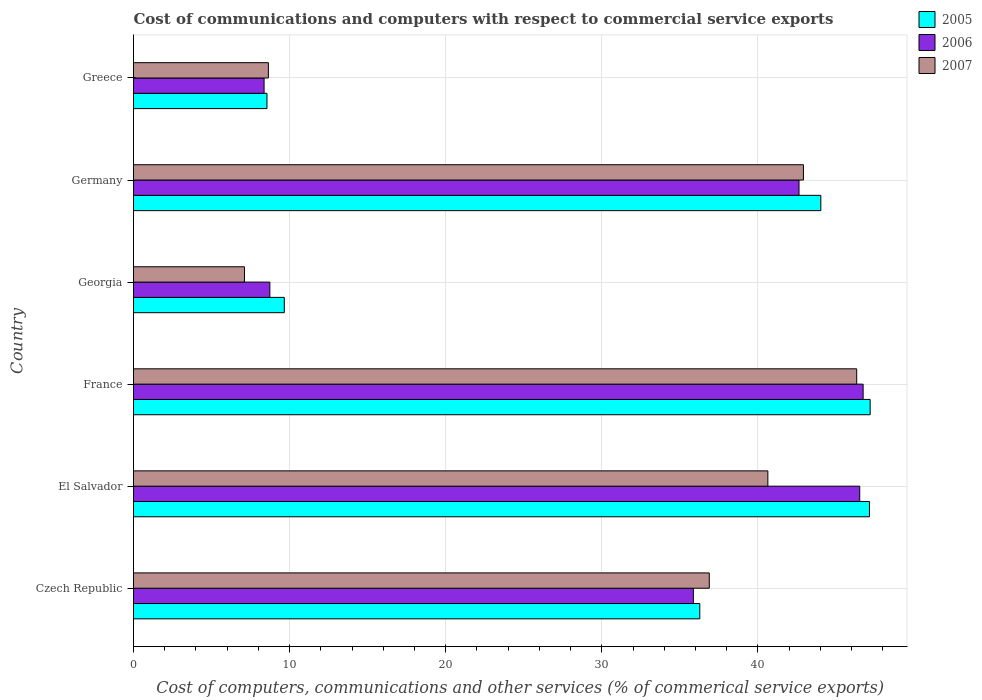How many different coloured bars are there?
Your response must be concise. 3. Are the number of bars per tick equal to the number of legend labels?
Your answer should be very brief. Yes. What is the label of the 5th group of bars from the top?
Offer a very short reply. El Salvador. In how many cases, is the number of bars for a given country not equal to the number of legend labels?
Provide a short and direct response. 0. What is the cost of communications and computers in 2005 in Czech Republic?
Provide a succinct answer. 36.28. Across all countries, what is the maximum cost of communications and computers in 2007?
Keep it short and to the point. 46.33. Across all countries, what is the minimum cost of communications and computers in 2007?
Your answer should be compact. 7.11. In which country was the cost of communications and computers in 2007 minimum?
Offer a terse response. Georgia. What is the total cost of communications and computers in 2006 in the graph?
Ensure brevity in your answer.  188.87. What is the difference between the cost of communications and computers in 2005 in El Salvador and that in Georgia?
Offer a terse response. 37.49. What is the difference between the cost of communications and computers in 2006 in Czech Republic and the cost of communications and computers in 2005 in Germany?
Give a very brief answer. -8.17. What is the average cost of communications and computers in 2007 per country?
Offer a terse response. 30.42. What is the difference between the cost of communications and computers in 2007 and cost of communications and computers in 2005 in Czech Republic?
Give a very brief answer. 0.61. In how many countries, is the cost of communications and computers in 2007 greater than 44 %?
Your response must be concise. 1. What is the ratio of the cost of communications and computers in 2006 in Germany to that in Greece?
Provide a short and direct response. 5.1. Is the cost of communications and computers in 2006 in Czech Republic less than that in Germany?
Provide a succinct answer. Yes. Is the difference between the cost of communications and computers in 2007 in El Salvador and France greater than the difference between the cost of communications and computers in 2005 in El Salvador and France?
Provide a succinct answer. No. What is the difference between the highest and the second highest cost of communications and computers in 2006?
Ensure brevity in your answer.  0.22. What is the difference between the highest and the lowest cost of communications and computers in 2005?
Offer a very short reply. 38.64. Is the sum of the cost of communications and computers in 2006 in Czech Republic and France greater than the maximum cost of communications and computers in 2007 across all countries?
Your response must be concise. Yes. How many bars are there?
Ensure brevity in your answer.  18. Are all the bars in the graph horizontal?
Keep it short and to the point. Yes. How many countries are there in the graph?
Give a very brief answer. 6. What is the difference between two consecutive major ticks on the X-axis?
Your answer should be very brief. 10. Does the graph contain grids?
Your response must be concise. Yes. How many legend labels are there?
Provide a succinct answer. 3. What is the title of the graph?
Offer a terse response. Cost of communications and computers with respect to commercial service exports. Does "1989" appear as one of the legend labels in the graph?
Provide a succinct answer. No. What is the label or title of the X-axis?
Your response must be concise. Cost of computers, communications and other services (% of commerical service exports). What is the label or title of the Y-axis?
Offer a very short reply. Country. What is the Cost of computers, communications and other services (% of commerical service exports) of 2005 in Czech Republic?
Make the answer very short. 36.28. What is the Cost of computers, communications and other services (% of commerical service exports) of 2006 in Czech Republic?
Provide a succinct answer. 35.87. What is the Cost of computers, communications and other services (% of commerical service exports) of 2007 in Czech Republic?
Your response must be concise. 36.89. What is the Cost of computers, communications and other services (% of commerical service exports) of 2005 in El Salvador?
Make the answer very short. 47.15. What is the Cost of computers, communications and other services (% of commerical service exports) of 2006 in El Salvador?
Give a very brief answer. 46.53. What is the Cost of computers, communications and other services (% of commerical service exports) of 2007 in El Salvador?
Keep it short and to the point. 40.64. What is the Cost of computers, communications and other services (% of commerical service exports) of 2005 in France?
Your response must be concise. 47.19. What is the Cost of computers, communications and other services (% of commerical service exports) in 2006 in France?
Provide a succinct answer. 46.74. What is the Cost of computers, communications and other services (% of commerical service exports) in 2007 in France?
Give a very brief answer. 46.33. What is the Cost of computers, communications and other services (% of commerical service exports) in 2005 in Georgia?
Your answer should be compact. 9.66. What is the Cost of computers, communications and other services (% of commerical service exports) in 2006 in Georgia?
Give a very brief answer. 8.74. What is the Cost of computers, communications and other services (% of commerical service exports) of 2007 in Georgia?
Your answer should be compact. 7.11. What is the Cost of computers, communications and other services (% of commerical service exports) in 2005 in Germany?
Keep it short and to the point. 44.03. What is the Cost of computers, communications and other services (% of commerical service exports) in 2006 in Germany?
Provide a succinct answer. 42.64. What is the Cost of computers, communications and other services (% of commerical service exports) in 2007 in Germany?
Provide a short and direct response. 42.92. What is the Cost of computers, communications and other services (% of commerical service exports) in 2005 in Greece?
Make the answer very short. 8.55. What is the Cost of computers, communications and other services (% of commerical service exports) of 2006 in Greece?
Your answer should be compact. 8.36. What is the Cost of computers, communications and other services (% of commerical service exports) in 2007 in Greece?
Offer a terse response. 8.64. Across all countries, what is the maximum Cost of computers, communications and other services (% of commerical service exports) in 2005?
Give a very brief answer. 47.19. Across all countries, what is the maximum Cost of computers, communications and other services (% of commerical service exports) in 2006?
Ensure brevity in your answer.  46.74. Across all countries, what is the maximum Cost of computers, communications and other services (% of commerical service exports) in 2007?
Give a very brief answer. 46.33. Across all countries, what is the minimum Cost of computers, communications and other services (% of commerical service exports) of 2005?
Give a very brief answer. 8.55. Across all countries, what is the minimum Cost of computers, communications and other services (% of commerical service exports) of 2006?
Provide a succinct answer. 8.36. Across all countries, what is the minimum Cost of computers, communications and other services (% of commerical service exports) of 2007?
Provide a short and direct response. 7.11. What is the total Cost of computers, communications and other services (% of commerical service exports) in 2005 in the graph?
Your answer should be compact. 192.87. What is the total Cost of computers, communications and other services (% of commerical service exports) of 2006 in the graph?
Keep it short and to the point. 188.87. What is the total Cost of computers, communications and other services (% of commerical service exports) in 2007 in the graph?
Your answer should be compact. 182.53. What is the difference between the Cost of computers, communications and other services (% of commerical service exports) of 2005 in Czech Republic and that in El Salvador?
Keep it short and to the point. -10.87. What is the difference between the Cost of computers, communications and other services (% of commerical service exports) in 2006 in Czech Republic and that in El Salvador?
Give a very brief answer. -10.66. What is the difference between the Cost of computers, communications and other services (% of commerical service exports) in 2007 in Czech Republic and that in El Salvador?
Offer a very short reply. -3.75. What is the difference between the Cost of computers, communications and other services (% of commerical service exports) in 2005 in Czech Republic and that in France?
Your response must be concise. -10.92. What is the difference between the Cost of computers, communications and other services (% of commerical service exports) in 2006 in Czech Republic and that in France?
Your answer should be compact. -10.88. What is the difference between the Cost of computers, communications and other services (% of commerical service exports) in 2007 in Czech Republic and that in France?
Offer a terse response. -9.44. What is the difference between the Cost of computers, communications and other services (% of commerical service exports) of 2005 in Czech Republic and that in Georgia?
Your response must be concise. 26.62. What is the difference between the Cost of computers, communications and other services (% of commerical service exports) in 2006 in Czech Republic and that in Georgia?
Ensure brevity in your answer.  27.13. What is the difference between the Cost of computers, communications and other services (% of commerical service exports) of 2007 in Czech Republic and that in Georgia?
Your response must be concise. 29.78. What is the difference between the Cost of computers, communications and other services (% of commerical service exports) of 2005 in Czech Republic and that in Germany?
Ensure brevity in your answer.  -7.75. What is the difference between the Cost of computers, communications and other services (% of commerical service exports) of 2006 in Czech Republic and that in Germany?
Your answer should be very brief. -6.77. What is the difference between the Cost of computers, communications and other services (% of commerical service exports) in 2007 in Czech Republic and that in Germany?
Your answer should be very brief. -6.03. What is the difference between the Cost of computers, communications and other services (% of commerical service exports) of 2005 in Czech Republic and that in Greece?
Provide a short and direct response. 27.73. What is the difference between the Cost of computers, communications and other services (% of commerical service exports) in 2006 in Czech Republic and that in Greece?
Your answer should be compact. 27.5. What is the difference between the Cost of computers, communications and other services (% of commerical service exports) in 2007 in Czech Republic and that in Greece?
Provide a short and direct response. 28.25. What is the difference between the Cost of computers, communications and other services (% of commerical service exports) in 2005 in El Salvador and that in France?
Offer a terse response. -0.04. What is the difference between the Cost of computers, communications and other services (% of commerical service exports) of 2006 in El Salvador and that in France?
Make the answer very short. -0.22. What is the difference between the Cost of computers, communications and other services (% of commerical service exports) of 2007 in El Salvador and that in France?
Give a very brief answer. -5.69. What is the difference between the Cost of computers, communications and other services (% of commerical service exports) of 2005 in El Salvador and that in Georgia?
Offer a very short reply. 37.49. What is the difference between the Cost of computers, communications and other services (% of commerical service exports) in 2006 in El Salvador and that in Georgia?
Offer a very short reply. 37.79. What is the difference between the Cost of computers, communications and other services (% of commerical service exports) of 2007 in El Salvador and that in Georgia?
Give a very brief answer. 33.53. What is the difference between the Cost of computers, communications and other services (% of commerical service exports) in 2005 in El Salvador and that in Germany?
Keep it short and to the point. 3.12. What is the difference between the Cost of computers, communications and other services (% of commerical service exports) in 2006 in El Salvador and that in Germany?
Provide a short and direct response. 3.89. What is the difference between the Cost of computers, communications and other services (% of commerical service exports) of 2007 in El Salvador and that in Germany?
Provide a succinct answer. -2.28. What is the difference between the Cost of computers, communications and other services (% of commerical service exports) of 2005 in El Salvador and that in Greece?
Your answer should be compact. 38.6. What is the difference between the Cost of computers, communications and other services (% of commerical service exports) of 2006 in El Salvador and that in Greece?
Provide a short and direct response. 38.16. What is the difference between the Cost of computers, communications and other services (% of commerical service exports) of 2007 in El Salvador and that in Greece?
Give a very brief answer. 32. What is the difference between the Cost of computers, communications and other services (% of commerical service exports) in 2005 in France and that in Georgia?
Keep it short and to the point. 37.53. What is the difference between the Cost of computers, communications and other services (% of commerical service exports) in 2006 in France and that in Georgia?
Your answer should be compact. 38.01. What is the difference between the Cost of computers, communications and other services (% of commerical service exports) of 2007 in France and that in Georgia?
Make the answer very short. 39.22. What is the difference between the Cost of computers, communications and other services (% of commerical service exports) of 2005 in France and that in Germany?
Offer a terse response. 3.16. What is the difference between the Cost of computers, communications and other services (% of commerical service exports) in 2006 in France and that in Germany?
Give a very brief answer. 4.11. What is the difference between the Cost of computers, communications and other services (% of commerical service exports) in 2007 in France and that in Germany?
Give a very brief answer. 3.41. What is the difference between the Cost of computers, communications and other services (% of commerical service exports) of 2005 in France and that in Greece?
Offer a terse response. 38.64. What is the difference between the Cost of computers, communications and other services (% of commerical service exports) in 2006 in France and that in Greece?
Your response must be concise. 38.38. What is the difference between the Cost of computers, communications and other services (% of commerical service exports) of 2007 in France and that in Greece?
Your answer should be compact. 37.69. What is the difference between the Cost of computers, communications and other services (% of commerical service exports) in 2005 in Georgia and that in Germany?
Make the answer very short. -34.37. What is the difference between the Cost of computers, communications and other services (% of commerical service exports) of 2006 in Georgia and that in Germany?
Make the answer very short. -33.9. What is the difference between the Cost of computers, communications and other services (% of commerical service exports) in 2007 in Georgia and that in Germany?
Give a very brief answer. -35.81. What is the difference between the Cost of computers, communications and other services (% of commerical service exports) of 2005 in Georgia and that in Greece?
Your answer should be compact. 1.11. What is the difference between the Cost of computers, communications and other services (% of commerical service exports) of 2006 in Georgia and that in Greece?
Your answer should be compact. 0.37. What is the difference between the Cost of computers, communications and other services (% of commerical service exports) in 2007 in Georgia and that in Greece?
Provide a short and direct response. -1.53. What is the difference between the Cost of computers, communications and other services (% of commerical service exports) in 2005 in Germany and that in Greece?
Give a very brief answer. 35.48. What is the difference between the Cost of computers, communications and other services (% of commerical service exports) in 2006 in Germany and that in Greece?
Keep it short and to the point. 34.27. What is the difference between the Cost of computers, communications and other services (% of commerical service exports) of 2007 in Germany and that in Greece?
Your response must be concise. 34.28. What is the difference between the Cost of computers, communications and other services (% of commerical service exports) in 2005 in Czech Republic and the Cost of computers, communications and other services (% of commerical service exports) in 2006 in El Salvador?
Make the answer very short. -10.25. What is the difference between the Cost of computers, communications and other services (% of commerical service exports) in 2005 in Czech Republic and the Cost of computers, communications and other services (% of commerical service exports) in 2007 in El Salvador?
Your response must be concise. -4.36. What is the difference between the Cost of computers, communications and other services (% of commerical service exports) in 2006 in Czech Republic and the Cost of computers, communications and other services (% of commerical service exports) in 2007 in El Salvador?
Offer a terse response. -4.77. What is the difference between the Cost of computers, communications and other services (% of commerical service exports) of 2005 in Czech Republic and the Cost of computers, communications and other services (% of commerical service exports) of 2006 in France?
Keep it short and to the point. -10.46. What is the difference between the Cost of computers, communications and other services (% of commerical service exports) in 2005 in Czech Republic and the Cost of computers, communications and other services (% of commerical service exports) in 2007 in France?
Provide a succinct answer. -10.05. What is the difference between the Cost of computers, communications and other services (% of commerical service exports) in 2006 in Czech Republic and the Cost of computers, communications and other services (% of commerical service exports) in 2007 in France?
Give a very brief answer. -10.46. What is the difference between the Cost of computers, communications and other services (% of commerical service exports) of 2005 in Czech Republic and the Cost of computers, communications and other services (% of commerical service exports) of 2006 in Georgia?
Provide a succinct answer. 27.54. What is the difference between the Cost of computers, communications and other services (% of commerical service exports) in 2005 in Czech Republic and the Cost of computers, communications and other services (% of commerical service exports) in 2007 in Georgia?
Your answer should be very brief. 29.17. What is the difference between the Cost of computers, communications and other services (% of commerical service exports) in 2006 in Czech Republic and the Cost of computers, communications and other services (% of commerical service exports) in 2007 in Georgia?
Offer a terse response. 28.76. What is the difference between the Cost of computers, communications and other services (% of commerical service exports) in 2005 in Czech Republic and the Cost of computers, communications and other services (% of commerical service exports) in 2006 in Germany?
Make the answer very short. -6.36. What is the difference between the Cost of computers, communications and other services (% of commerical service exports) of 2005 in Czech Republic and the Cost of computers, communications and other services (% of commerical service exports) of 2007 in Germany?
Your answer should be compact. -6.64. What is the difference between the Cost of computers, communications and other services (% of commerical service exports) in 2006 in Czech Republic and the Cost of computers, communications and other services (% of commerical service exports) in 2007 in Germany?
Provide a short and direct response. -7.05. What is the difference between the Cost of computers, communications and other services (% of commerical service exports) of 2005 in Czech Republic and the Cost of computers, communications and other services (% of commerical service exports) of 2006 in Greece?
Make the answer very short. 27.91. What is the difference between the Cost of computers, communications and other services (% of commerical service exports) of 2005 in Czech Republic and the Cost of computers, communications and other services (% of commerical service exports) of 2007 in Greece?
Make the answer very short. 27.64. What is the difference between the Cost of computers, communications and other services (% of commerical service exports) in 2006 in Czech Republic and the Cost of computers, communications and other services (% of commerical service exports) in 2007 in Greece?
Make the answer very short. 27.23. What is the difference between the Cost of computers, communications and other services (% of commerical service exports) in 2005 in El Salvador and the Cost of computers, communications and other services (% of commerical service exports) in 2006 in France?
Give a very brief answer. 0.41. What is the difference between the Cost of computers, communications and other services (% of commerical service exports) in 2005 in El Salvador and the Cost of computers, communications and other services (% of commerical service exports) in 2007 in France?
Your answer should be compact. 0.82. What is the difference between the Cost of computers, communications and other services (% of commerical service exports) of 2006 in El Salvador and the Cost of computers, communications and other services (% of commerical service exports) of 2007 in France?
Make the answer very short. 0.19. What is the difference between the Cost of computers, communications and other services (% of commerical service exports) in 2005 in El Salvador and the Cost of computers, communications and other services (% of commerical service exports) in 2006 in Georgia?
Your answer should be compact. 38.41. What is the difference between the Cost of computers, communications and other services (% of commerical service exports) in 2005 in El Salvador and the Cost of computers, communications and other services (% of commerical service exports) in 2007 in Georgia?
Your answer should be very brief. 40.04. What is the difference between the Cost of computers, communications and other services (% of commerical service exports) of 2006 in El Salvador and the Cost of computers, communications and other services (% of commerical service exports) of 2007 in Georgia?
Offer a very short reply. 39.42. What is the difference between the Cost of computers, communications and other services (% of commerical service exports) in 2005 in El Salvador and the Cost of computers, communications and other services (% of commerical service exports) in 2006 in Germany?
Your response must be concise. 4.51. What is the difference between the Cost of computers, communications and other services (% of commerical service exports) of 2005 in El Salvador and the Cost of computers, communications and other services (% of commerical service exports) of 2007 in Germany?
Make the answer very short. 4.23. What is the difference between the Cost of computers, communications and other services (% of commerical service exports) of 2006 in El Salvador and the Cost of computers, communications and other services (% of commerical service exports) of 2007 in Germany?
Give a very brief answer. 3.61. What is the difference between the Cost of computers, communications and other services (% of commerical service exports) of 2005 in El Salvador and the Cost of computers, communications and other services (% of commerical service exports) of 2006 in Greece?
Provide a short and direct response. 38.78. What is the difference between the Cost of computers, communications and other services (% of commerical service exports) in 2005 in El Salvador and the Cost of computers, communications and other services (% of commerical service exports) in 2007 in Greece?
Your answer should be very brief. 38.51. What is the difference between the Cost of computers, communications and other services (% of commerical service exports) in 2006 in El Salvador and the Cost of computers, communications and other services (% of commerical service exports) in 2007 in Greece?
Make the answer very short. 37.89. What is the difference between the Cost of computers, communications and other services (% of commerical service exports) in 2005 in France and the Cost of computers, communications and other services (% of commerical service exports) in 2006 in Georgia?
Keep it short and to the point. 38.46. What is the difference between the Cost of computers, communications and other services (% of commerical service exports) in 2005 in France and the Cost of computers, communications and other services (% of commerical service exports) in 2007 in Georgia?
Your answer should be compact. 40.09. What is the difference between the Cost of computers, communications and other services (% of commerical service exports) in 2006 in France and the Cost of computers, communications and other services (% of commerical service exports) in 2007 in Georgia?
Make the answer very short. 39.64. What is the difference between the Cost of computers, communications and other services (% of commerical service exports) of 2005 in France and the Cost of computers, communications and other services (% of commerical service exports) of 2006 in Germany?
Your response must be concise. 4.56. What is the difference between the Cost of computers, communications and other services (% of commerical service exports) of 2005 in France and the Cost of computers, communications and other services (% of commerical service exports) of 2007 in Germany?
Provide a short and direct response. 4.28. What is the difference between the Cost of computers, communications and other services (% of commerical service exports) in 2006 in France and the Cost of computers, communications and other services (% of commerical service exports) in 2007 in Germany?
Ensure brevity in your answer.  3.83. What is the difference between the Cost of computers, communications and other services (% of commerical service exports) in 2005 in France and the Cost of computers, communications and other services (% of commerical service exports) in 2006 in Greece?
Your answer should be compact. 38.83. What is the difference between the Cost of computers, communications and other services (% of commerical service exports) in 2005 in France and the Cost of computers, communications and other services (% of commerical service exports) in 2007 in Greece?
Ensure brevity in your answer.  38.55. What is the difference between the Cost of computers, communications and other services (% of commerical service exports) in 2006 in France and the Cost of computers, communications and other services (% of commerical service exports) in 2007 in Greece?
Your response must be concise. 38.1. What is the difference between the Cost of computers, communications and other services (% of commerical service exports) in 2005 in Georgia and the Cost of computers, communications and other services (% of commerical service exports) in 2006 in Germany?
Give a very brief answer. -32.98. What is the difference between the Cost of computers, communications and other services (% of commerical service exports) of 2005 in Georgia and the Cost of computers, communications and other services (% of commerical service exports) of 2007 in Germany?
Your response must be concise. -33.26. What is the difference between the Cost of computers, communications and other services (% of commerical service exports) in 2006 in Georgia and the Cost of computers, communications and other services (% of commerical service exports) in 2007 in Germany?
Provide a short and direct response. -34.18. What is the difference between the Cost of computers, communications and other services (% of commerical service exports) of 2005 in Georgia and the Cost of computers, communications and other services (% of commerical service exports) of 2006 in Greece?
Provide a succinct answer. 1.3. What is the difference between the Cost of computers, communications and other services (% of commerical service exports) in 2005 in Georgia and the Cost of computers, communications and other services (% of commerical service exports) in 2007 in Greece?
Offer a terse response. 1.02. What is the difference between the Cost of computers, communications and other services (% of commerical service exports) in 2006 in Georgia and the Cost of computers, communications and other services (% of commerical service exports) in 2007 in Greece?
Provide a short and direct response. 0.1. What is the difference between the Cost of computers, communications and other services (% of commerical service exports) of 2005 in Germany and the Cost of computers, communications and other services (% of commerical service exports) of 2006 in Greece?
Your answer should be compact. 35.67. What is the difference between the Cost of computers, communications and other services (% of commerical service exports) of 2005 in Germany and the Cost of computers, communications and other services (% of commerical service exports) of 2007 in Greece?
Provide a succinct answer. 35.39. What is the difference between the Cost of computers, communications and other services (% of commerical service exports) in 2006 in Germany and the Cost of computers, communications and other services (% of commerical service exports) in 2007 in Greece?
Offer a terse response. 34. What is the average Cost of computers, communications and other services (% of commerical service exports) of 2005 per country?
Your answer should be very brief. 32.14. What is the average Cost of computers, communications and other services (% of commerical service exports) in 2006 per country?
Your answer should be compact. 31.48. What is the average Cost of computers, communications and other services (% of commerical service exports) in 2007 per country?
Give a very brief answer. 30.42. What is the difference between the Cost of computers, communications and other services (% of commerical service exports) in 2005 and Cost of computers, communications and other services (% of commerical service exports) in 2006 in Czech Republic?
Your answer should be compact. 0.41. What is the difference between the Cost of computers, communications and other services (% of commerical service exports) in 2005 and Cost of computers, communications and other services (% of commerical service exports) in 2007 in Czech Republic?
Offer a very short reply. -0.61. What is the difference between the Cost of computers, communications and other services (% of commerical service exports) in 2006 and Cost of computers, communications and other services (% of commerical service exports) in 2007 in Czech Republic?
Your answer should be very brief. -1.02. What is the difference between the Cost of computers, communications and other services (% of commerical service exports) in 2005 and Cost of computers, communications and other services (% of commerical service exports) in 2006 in El Salvador?
Your answer should be compact. 0.62. What is the difference between the Cost of computers, communications and other services (% of commerical service exports) in 2005 and Cost of computers, communications and other services (% of commerical service exports) in 2007 in El Salvador?
Provide a succinct answer. 6.51. What is the difference between the Cost of computers, communications and other services (% of commerical service exports) in 2006 and Cost of computers, communications and other services (% of commerical service exports) in 2007 in El Salvador?
Ensure brevity in your answer.  5.89. What is the difference between the Cost of computers, communications and other services (% of commerical service exports) of 2005 and Cost of computers, communications and other services (% of commerical service exports) of 2006 in France?
Offer a very short reply. 0.45. What is the difference between the Cost of computers, communications and other services (% of commerical service exports) in 2005 and Cost of computers, communications and other services (% of commerical service exports) in 2007 in France?
Provide a succinct answer. 0.86. What is the difference between the Cost of computers, communications and other services (% of commerical service exports) in 2006 and Cost of computers, communications and other services (% of commerical service exports) in 2007 in France?
Ensure brevity in your answer.  0.41. What is the difference between the Cost of computers, communications and other services (% of commerical service exports) in 2005 and Cost of computers, communications and other services (% of commerical service exports) in 2006 in Georgia?
Provide a short and direct response. 0.93. What is the difference between the Cost of computers, communications and other services (% of commerical service exports) in 2005 and Cost of computers, communications and other services (% of commerical service exports) in 2007 in Georgia?
Provide a succinct answer. 2.55. What is the difference between the Cost of computers, communications and other services (% of commerical service exports) in 2006 and Cost of computers, communications and other services (% of commerical service exports) in 2007 in Georgia?
Your answer should be very brief. 1.63. What is the difference between the Cost of computers, communications and other services (% of commerical service exports) of 2005 and Cost of computers, communications and other services (% of commerical service exports) of 2006 in Germany?
Provide a succinct answer. 1.4. What is the difference between the Cost of computers, communications and other services (% of commerical service exports) in 2005 and Cost of computers, communications and other services (% of commerical service exports) in 2007 in Germany?
Ensure brevity in your answer.  1.11. What is the difference between the Cost of computers, communications and other services (% of commerical service exports) of 2006 and Cost of computers, communications and other services (% of commerical service exports) of 2007 in Germany?
Make the answer very short. -0.28. What is the difference between the Cost of computers, communications and other services (% of commerical service exports) in 2005 and Cost of computers, communications and other services (% of commerical service exports) in 2006 in Greece?
Your answer should be very brief. 0.19. What is the difference between the Cost of computers, communications and other services (% of commerical service exports) in 2005 and Cost of computers, communications and other services (% of commerical service exports) in 2007 in Greece?
Provide a short and direct response. -0.09. What is the difference between the Cost of computers, communications and other services (% of commerical service exports) in 2006 and Cost of computers, communications and other services (% of commerical service exports) in 2007 in Greece?
Offer a terse response. -0.28. What is the ratio of the Cost of computers, communications and other services (% of commerical service exports) of 2005 in Czech Republic to that in El Salvador?
Keep it short and to the point. 0.77. What is the ratio of the Cost of computers, communications and other services (% of commerical service exports) of 2006 in Czech Republic to that in El Salvador?
Make the answer very short. 0.77. What is the ratio of the Cost of computers, communications and other services (% of commerical service exports) of 2007 in Czech Republic to that in El Salvador?
Ensure brevity in your answer.  0.91. What is the ratio of the Cost of computers, communications and other services (% of commerical service exports) in 2005 in Czech Republic to that in France?
Your answer should be very brief. 0.77. What is the ratio of the Cost of computers, communications and other services (% of commerical service exports) of 2006 in Czech Republic to that in France?
Give a very brief answer. 0.77. What is the ratio of the Cost of computers, communications and other services (% of commerical service exports) of 2007 in Czech Republic to that in France?
Your answer should be very brief. 0.8. What is the ratio of the Cost of computers, communications and other services (% of commerical service exports) in 2005 in Czech Republic to that in Georgia?
Provide a succinct answer. 3.76. What is the ratio of the Cost of computers, communications and other services (% of commerical service exports) of 2006 in Czech Republic to that in Georgia?
Offer a very short reply. 4.11. What is the ratio of the Cost of computers, communications and other services (% of commerical service exports) of 2007 in Czech Republic to that in Georgia?
Give a very brief answer. 5.19. What is the ratio of the Cost of computers, communications and other services (% of commerical service exports) of 2005 in Czech Republic to that in Germany?
Your answer should be very brief. 0.82. What is the ratio of the Cost of computers, communications and other services (% of commerical service exports) of 2006 in Czech Republic to that in Germany?
Make the answer very short. 0.84. What is the ratio of the Cost of computers, communications and other services (% of commerical service exports) of 2007 in Czech Republic to that in Germany?
Give a very brief answer. 0.86. What is the ratio of the Cost of computers, communications and other services (% of commerical service exports) in 2005 in Czech Republic to that in Greece?
Make the answer very short. 4.24. What is the ratio of the Cost of computers, communications and other services (% of commerical service exports) of 2006 in Czech Republic to that in Greece?
Provide a short and direct response. 4.29. What is the ratio of the Cost of computers, communications and other services (% of commerical service exports) in 2007 in Czech Republic to that in Greece?
Keep it short and to the point. 4.27. What is the ratio of the Cost of computers, communications and other services (% of commerical service exports) of 2006 in El Salvador to that in France?
Give a very brief answer. 1. What is the ratio of the Cost of computers, communications and other services (% of commerical service exports) in 2007 in El Salvador to that in France?
Keep it short and to the point. 0.88. What is the ratio of the Cost of computers, communications and other services (% of commerical service exports) in 2005 in El Salvador to that in Georgia?
Your response must be concise. 4.88. What is the ratio of the Cost of computers, communications and other services (% of commerical service exports) in 2006 in El Salvador to that in Georgia?
Keep it short and to the point. 5.33. What is the ratio of the Cost of computers, communications and other services (% of commerical service exports) in 2007 in El Salvador to that in Georgia?
Provide a succinct answer. 5.72. What is the ratio of the Cost of computers, communications and other services (% of commerical service exports) of 2005 in El Salvador to that in Germany?
Offer a terse response. 1.07. What is the ratio of the Cost of computers, communications and other services (% of commerical service exports) in 2006 in El Salvador to that in Germany?
Ensure brevity in your answer.  1.09. What is the ratio of the Cost of computers, communications and other services (% of commerical service exports) of 2007 in El Salvador to that in Germany?
Provide a succinct answer. 0.95. What is the ratio of the Cost of computers, communications and other services (% of commerical service exports) in 2005 in El Salvador to that in Greece?
Your answer should be very brief. 5.51. What is the ratio of the Cost of computers, communications and other services (% of commerical service exports) of 2006 in El Salvador to that in Greece?
Provide a short and direct response. 5.56. What is the ratio of the Cost of computers, communications and other services (% of commerical service exports) of 2007 in El Salvador to that in Greece?
Your response must be concise. 4.7. What is the ratio of the Cost of computers, communications and other services (% of commerical service exports) of 2005 in France to that in Georgia?
Your response must be concise. 4.89. What is the ratio of the Cost of computers, communications and other services (% of commerical service exports) of 2006 in France to that in Georgia?
Make the answer very short. 5.35. What is the ratio of the Cost of computers, communications and other services (% of commerical service exports) in 2007 in France to that in Georgia?
Make the answer very short. 6.52. What is the ratio of the Cost of computers, communications and other services (% of commerical service exports) of 2005 in France to that in Germany?
Keep it short and to the point. 1.07. What is the ratio of the Cost of computers, communications and other services (% of commerical service exports) in 2006 in France to that in Germany?
Your response must be concise. 1.1. What is the ratio of the Cost of computers, communications and other services (% of commerical service exports) of 2007 in France to that in Germany?
Ensure brevity in your answer.  1.08. What is the ratio of the Cost of computers, communications and other services (% of commerical service exports) of 2005 in France to that in Greece?
Your answer should be compact. 5.52. What is the ratio of the Cost of computers, communications and other services (% of commerical service exports) of 2006 in France to that in Greece?
Offer a very short reply. 5.59. What is the ratio of the Cost of computers, communications and other services (% of commerical service exports) of 2007 in France to that in Greece?
Offer a very short reply. 5.36. What is the ratio of the Cost of computers, communications and other services (% of commerical service exports) of 2005 in Georgia to that in Germany?
Offer a terse response. 0.22. What is the ratio of the Cost of computers, communications and other services (% of commerical service exports) of 2006 in Georgia to that in Germany?
Give a very brief answer. 0.2. What is the ratio of the Cost of computers, communications and other services (% of commerical service exports) of 2007 in Georgia to that in Germany?
Offer a very short reply. 0.17. What is the ratio of the Cost of computers, communications and other services (% of commerical service exports) of 2005 in Georgia to that in Greece?
Offer a very short reply. 1.13. What is the ratio of the Cost of computers, communications and other services (% of commerical service exports) of 2006 in Georgia to that in Greece?
Your response must be concise. 1.04. What is the ratio of the Cost of computers, communications and other services (% of commerical service exports) of 2007 in Georgia to that in Greece?
Offer a very short reply. 0.82. What is the ratio of the Cost of computers, communications and other services (% of commerical service exports) of 2005 in Germany to that in Greece?
Offer a terse response. 5.15. What is the ratio of the Cost of computers, communications and other services (% of commerical service exports) in 2006 in Germany to that in Greece?
Give a very brief answer. 5.1. What is the ratio of the Cost of computers, communications and other services (% of commerical service exports) of 2007 in Germany to that in Greece?
Make the answer very short. 4.97. What is the difference between the highest and the second highest Cost of computers, communications and other services (% of commerical service exports) in 2005?
Ensure brevity in your answer.  0.04. What is the difference between the highest and the second highest Cost of computers, communications and other services (% of commerical service exports) in 2006?
Offer a very short reply. 0.22. What is the difference between the highest and the second highest Cost of computers, communications and other services (% of commerical service exports) in 2007?
Your answer should be very brief. 3.41. What is the difference between the highest and the lowest Cost of computers, communications and other services (% of commerical service exports) of 2005?
Provide a succinct answer. 38.64. What is the difference between the highest and the lowest Cost of computers, communications and other services (% of commerical service exports) of 2006?
Your response must be concise. 38.38. What is the difference between the highest and the lowest Cost of computers, communications and other services (% of commerical service exports) of 2007?
Give a very brief answer. 39.22. 